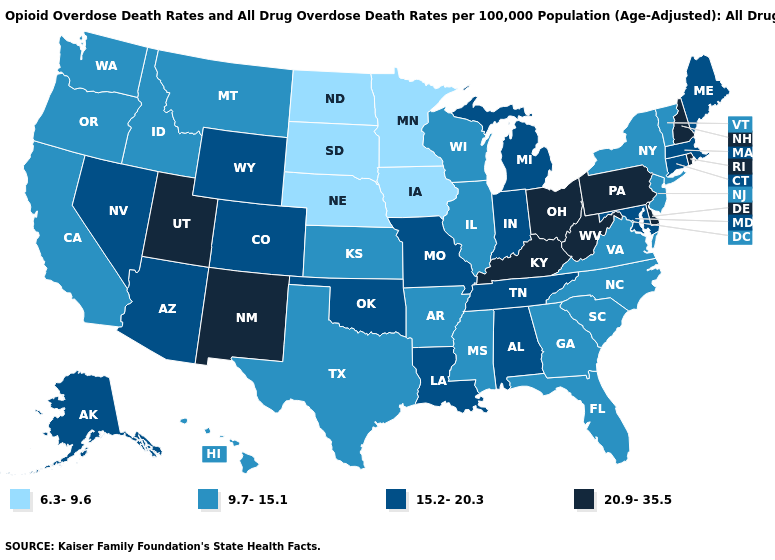Which states hav the highest value in the MidWest?
Concise answer only. Ohio. What is the value of Virginia?
Concise answer only. 9.7-15.1. Which states have the highest value in the USA?
Quick response, please. Delaware, Kentucky, New Hampshire, New Mexico, Ohio, Pennsylvania, Rhode Island, Utah, West Virginia. What is the value of North Dakota?
Keep it brief. 6.3-9.6. How many symbols are there in the legend?
Quick response, please. 4. What is the value of Hawaii?
Give a very brief answer. 9.7-15.1. Does South Carolina have the highest value in the USA?
Write a very short answer. No. What is the value of Nevada?
Quick response, please. 15.2-20.3. What is the value of Idaho?
Answer briefly. 9.7-15.1. Among the states that border Nevada , which have the lowest value?
Answer briefly. California, Idaho, Oregon. What is the highest value in the USA?
Write a very short answer. 20.9-35.5. Name the states that have a value in the range 20.9-35.5?
Give a very brief answer. Delaware, Kentucky, New Hampshire, New Mexico, Ohio, Pennsylvania, Rhode Island, Utah, West Virginia. Name the states that have a value in the range 6.3-9.6?
Answer briefly. Iowa, Minnesota, Nebraska, North Dakota, South Dakota. 